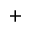Convert formula to latex. <formula><loc_0><loc_0><loc_500><loc_500>^ { + }</formula> 